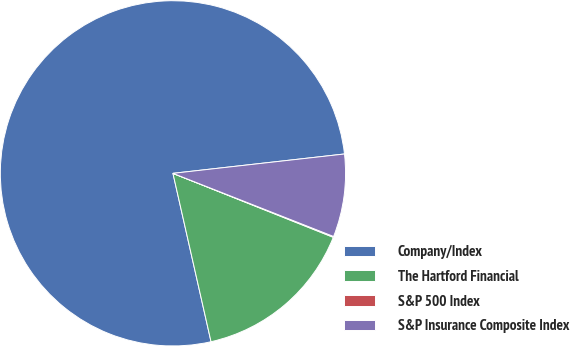Convert chart to OTSL. <chart><loc_0><loc_0><loc_500><loc_500><pie_chart><fcel>Company/Index<fcel>The Hartford Financial<fcel>S&P 500 Index<fcel>S&P Insurance Composite Index<nl><fcel>76.76%<fcel>15.42%<fcel>0.08%<fcel>7.75%<nl></chart> 